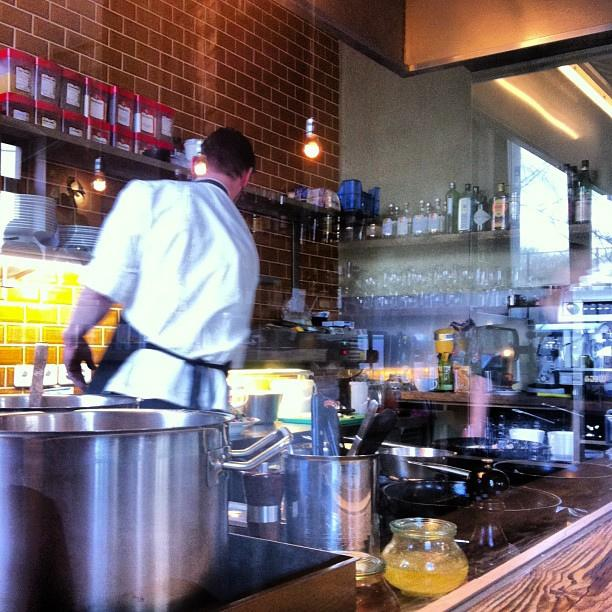What is on the counter? pots 